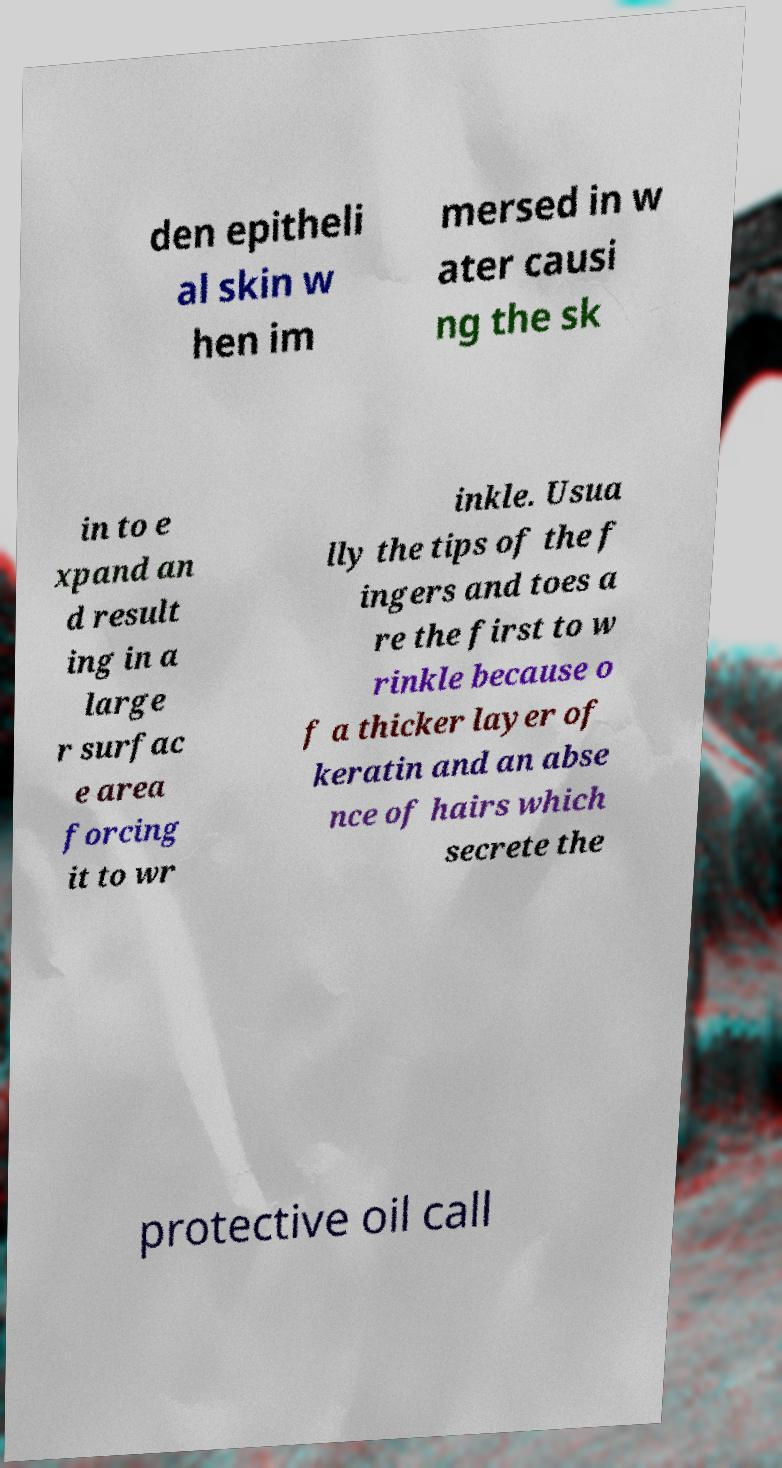For documentation purposes, I need the text within this image transcribed. Could you provide that? den epitheli al skin w hen im mersed in w ater causi ng the sk in to e xpand an d result ing in a large r surfac e area forcing it to wr inkle. Usua lly the tips of the f ingers and toes a re the first to w rinkle because o f a thicker layer of keratin and an abse nce of hairs which secrete the protective oil call 